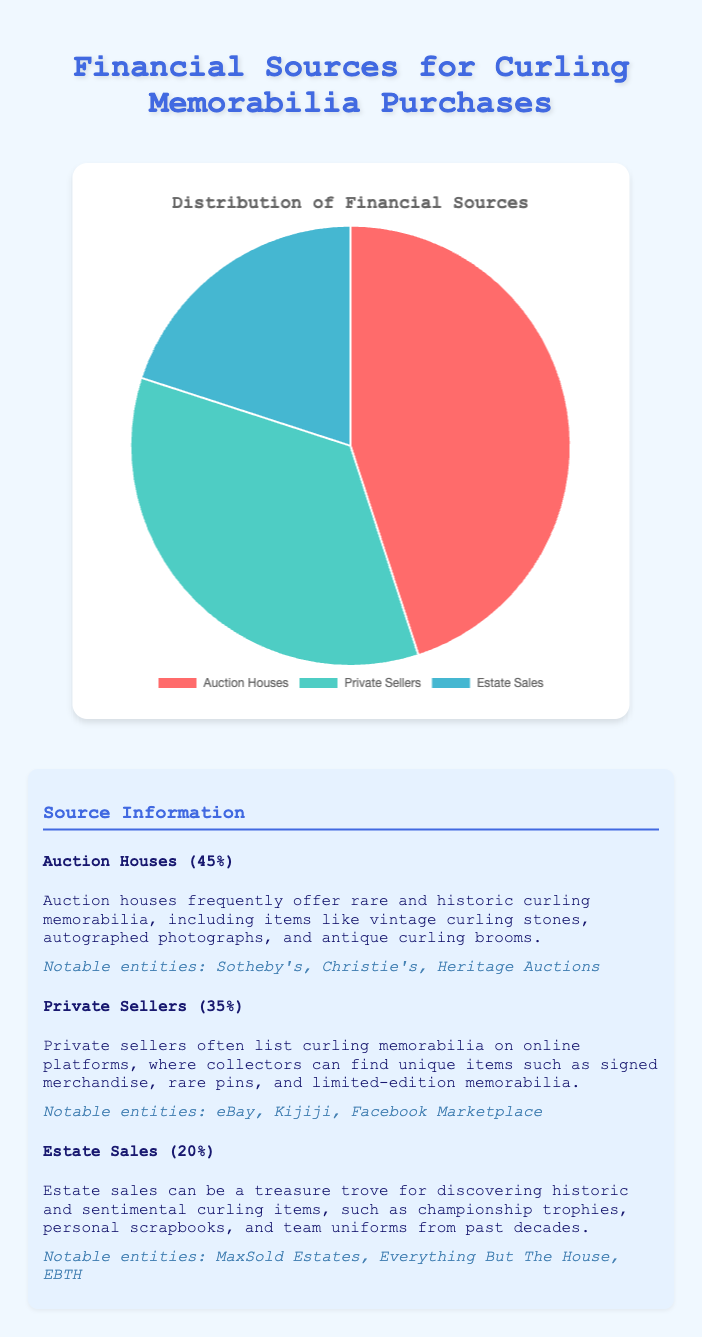What is the most significant source of financial support for acquiring curling memorabilia? To answer, look at the pie chart and identify which segment occupies the largest portion. Auction Houses have the highest percentage at 45%.
Answer: Auction Houses Which source contributes exactly 35% to the total financial support? To find this, look at the chart and match the percentage values to the sources. Private Sellers contribute 35%.
Answer: Private Sellers What is the combined percentage of financial support from Private Sellers and Estate Sales? Add the percentages of Private Sellers (35%) and Estate Sales (20%). 35 + 20 = 55%
Answer: 55% Which two sources together provide more than half of the financial support? Check each combination of two sources. Auction Houses (45%) and Private Sellers (35%) combined provide 80%, which is more than 50%.
Answer: Auction Houses and Private Sellers What is the difference in financial support between the highest and lowest sources? Subtract the smallest percentage (Estate Sales at 20%) from the largest percentage (Auction Houses at 45%). 45 - 20 = 25%
Answer: 25% If the support from Private Sellers increased by 10%, what would their new percentage be? Add 10% to the current percentage of Private Sellers (35%). 35 + 10 = 45%
Answer: 45% How does the size of the slice for Estate Sales compare to the slice for Private Sellers in terms of percentages? Look at the chart and compare the two percentages. Private Sellers (35%) is larger than Estate Sales (20%).
Answer: Larger What color represents the Auction Houses segment in the pie chart? Identify the color of the slice corresponding to Auction Houses by examining the chart. Auction Houses are represented by the color red.
Answer: Red Which segment is represented by the green color in the chart? Look at the color-coded segments and match green to its corresponding source. Private Sellers are represented by the green color.
Answer: Private Sellers 